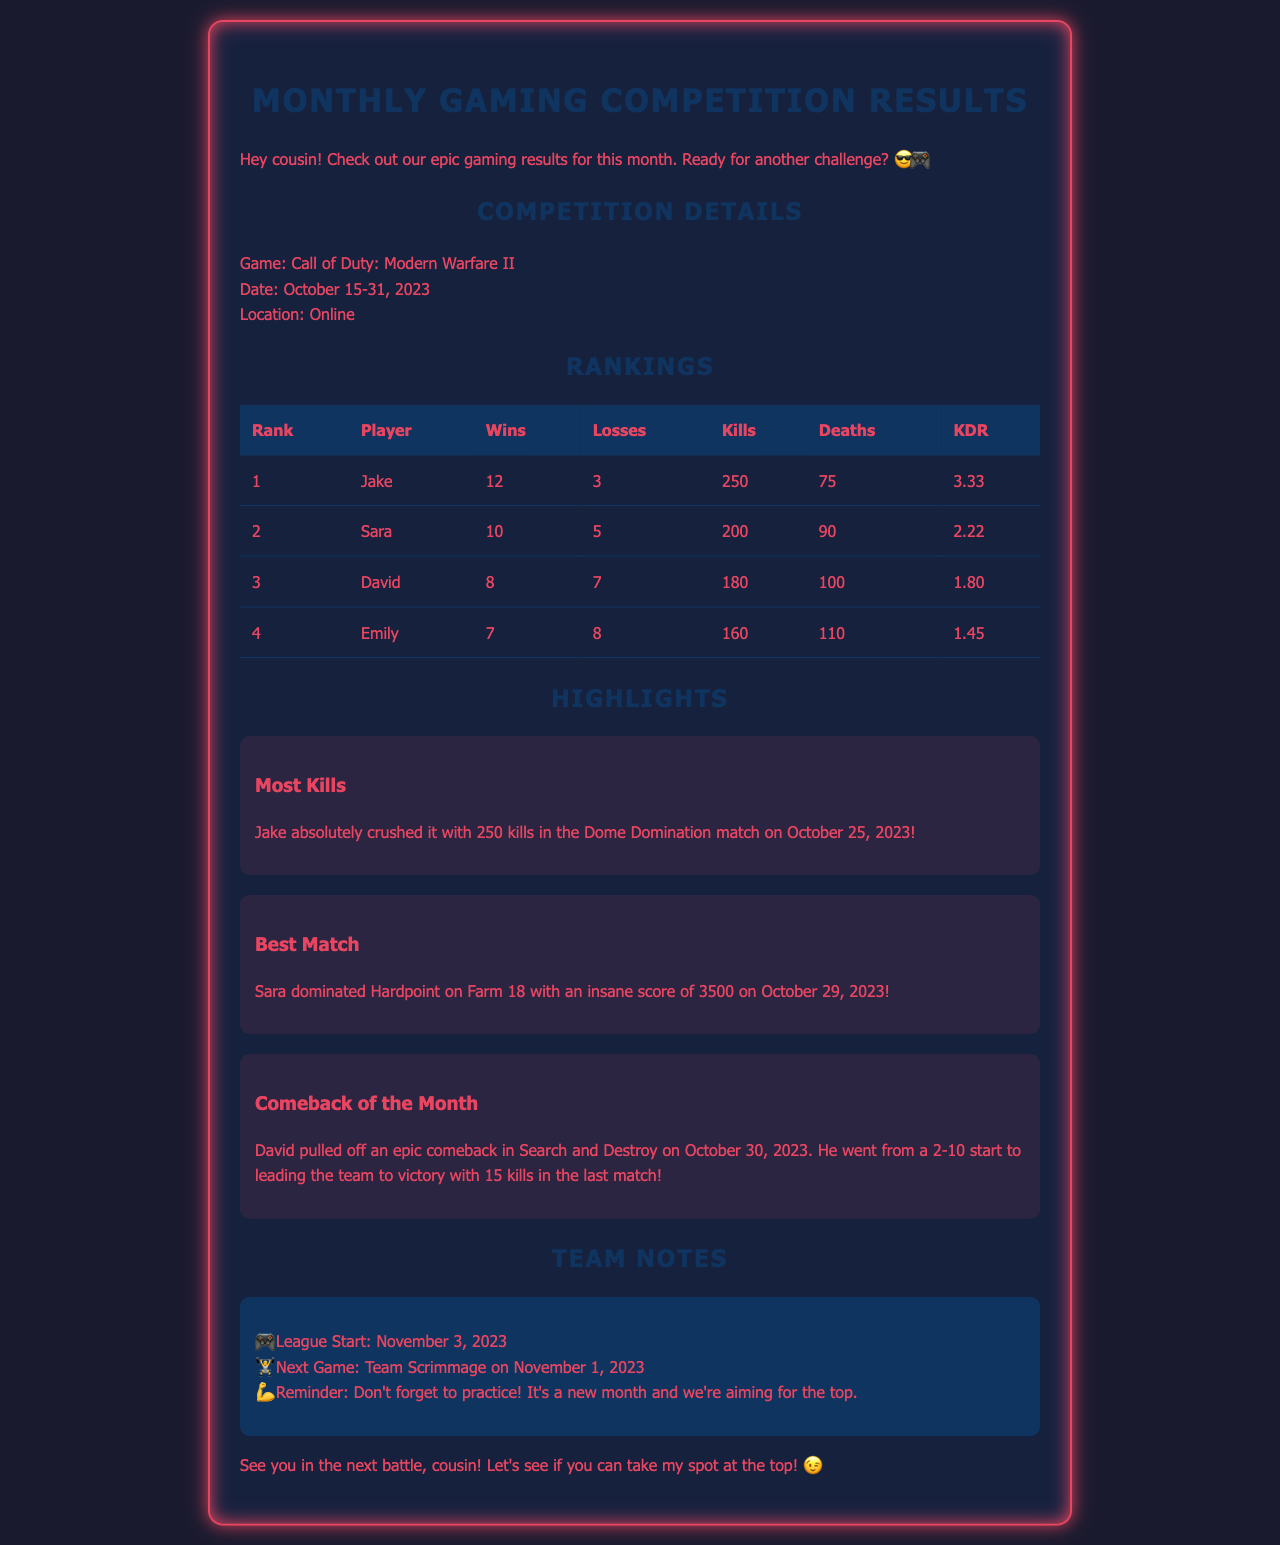What is the title of the document? The title of the document is indicated at the top as "Monthly Gaming Competition Results."
Answer: Monthly Gaming Competition Results Who scored the most kills? The document highlights that Jake had the most kills in the competition, totaling 250.
Answer: Jake How many wins did Sara achieve? According to the rankings table, Sara achieved 10 wins during the competition.
Answer: 10 What was David's kill-to-death ratio? The document specifies that David's kill-to-death ratio (KDR) is 1.80.
Answer: 1.80 What date does the league start? The document mentions that the league starts on November 3, 2023.
Answer: November 3, 2023 Which match was noted as the Best Match? The highlight section states that Sara's performance in Hardpoint on Farm 18 is noted as the Best Match.
Answer: Hardpoint on Farm 18 How many players had more losses than wins? The document lists 2 players, David and Emily, who had more losses than wins: David with 7 losses and Emily with 8.
Answer: 2 When did the competition take place? The competition took place from October 15 to October 31, 2023.
Answer: October 15-31, 2023 What is the next scheduled team event? The document indicates that the next scheduled team event is a Team Scrimmage on November 1, 2023.
Answer: Team Scrimmage on November 1, 2023 